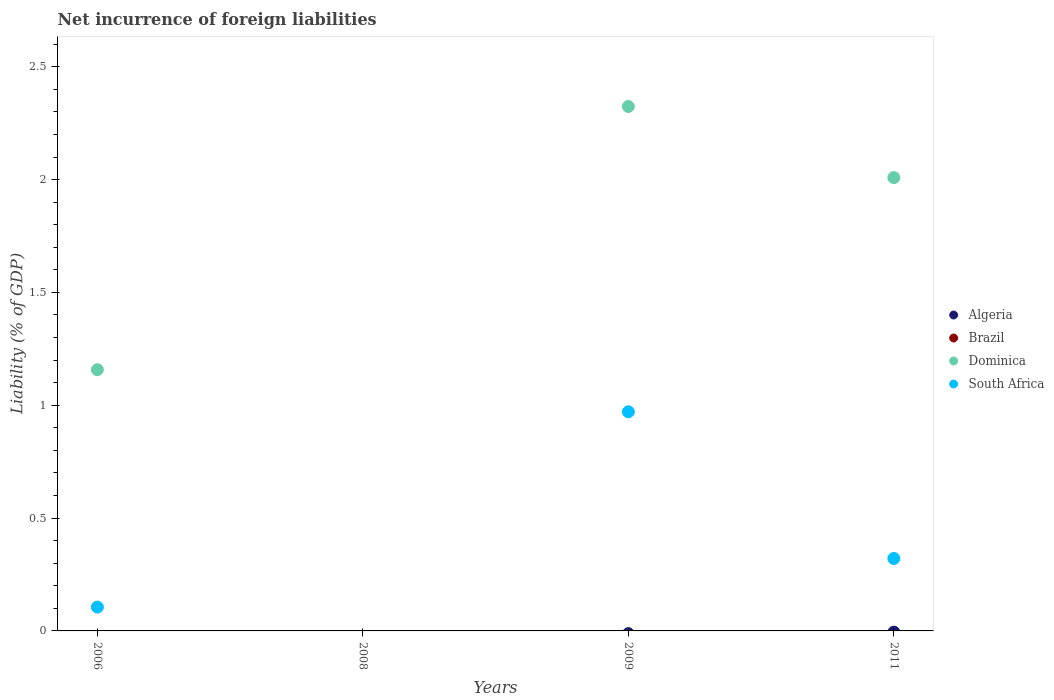What is the net incurrence of foreign liabilities in South Africa in 2011?
Your answer should be compact. 0.32. Across all years, what is the minimum net incurrence of foreign liabilities in South Africa?
Give a very brief answer. 0. What is the difference between the net incurrence of foreign liabilities in Dominica in 2011 and the net incurrence of foreign liabilities in Algeria in 2008?
Make the answer very short. 2.01. What is the average net incurrence of foreign liabilities in Algeria per year?
Provide a short and direct response. 0. In the year 2006, what is the difference between the net incurrence of foreign liabilities in Dominica and net incurrence of foreign liabilities in South Africa?
Offer a terse response. 1.05. In how many years, is the net incurrence of foreign liabilities in Algeria greater than 1.6 %?
Ensure brevity in your answer.  0. Is the difference between the net incurrence of foreign liabilities in Dominica in 2009 and 2011 greater than the difference between the net incurrence of foreign liabilities in South Africa in 2009 and 2011?
Give a very brief answer. No. What is the difference between the highest and the lowest net incurrence of foreign liabilities in Dominica?
Keep it short and to the point. 2.32. In how many years, is the net incurrence of foreign liabilities in Algeria greater than the average net incurrence of foreign liabilities in Algeria taken over all years?
Provide a succinct answer. 0. Is it the case that in every year, the sum of the net incurrence of foreign liabilities in South Africa and net incurrence of foreign liabilities in Dominica  is greater than the net incurrence of foreign liabilities in Algeria?
Offer a terse response. No. Are the values on the major ticks of Y-axis written in scientific E-notation?
Your answer should be very brief. No. Where does the legend appear in the graph?
Offer a terse response. Center right. What is the title of the graph?
Keep it short and to the point. Net incurrence of foreign liabilities. Does "Comoros" appear as one of the legend labels in the graph?
Your answer should be compact. No. What is the label or title of the X-axis?
Offer a terse response. Years. What is the label or title of the Y-axis?
Provide a succinct answer. Liability (% of GDP). What is the Liability (% of GDP) of Brazil in 2006?
Your answer should be very brief. 0. What is the Liability (% of GDP) in Dominica in 2006?
Your response must be concise. 1.16. What is the Liability (% of GDP) of South Africa in 2006?
Give a very brief answer. 0.11. What is the Liability (% of GDP) of Algeria in 2008?
Make the answer very short. 0. What is the Liability (% of GDP) of Dominica in 2008?
Provide a short and direct response. 0. What is the Liability (% of GDP) in Algeria in 2009?
Ensure brevity in your answer.  0. What is the Liability (% of GDP) in Dominica in 2009?
Ensure brevity in your answer.  2.32. What is the Liability (% of GDP) in South Africa in 2009?
Provide a succinct answer. 0.97. What is the Liability (% of GDP) in Brazil in 2011?
Offer a terse response. 0. What is the Liability (% of GDP) in Dominica in 2011?
Offer a very short reply. 2.01. What is the Liability (% of GDP) of South Africa in 2011?
Keep it short and to the point. 0.32. Across all years, what is the maximum Liability (% of GDP) of Dominica?
Ensure brevity in your answer.  2.32. Across all years, what is the maximum Liability (% of GDP) in South Africa?
Offer a terse response. 0.97. Across all years, what is the minimum Liability (% of GDP) in Dominica?
Offer a very short reply. 0. Across all years, what is the minimum Liability (% of GDP) in South Africa?
Provide a succinct answer. 0. What is the total Liability (% of GDP) of Dominica in the graph?
Ensure brevity in your answer.  5.49. What is the total Liability (% of GDP) of South Africa in the graph?
Ensure brevity in your answer.  1.4. What is the difference between the Liability (% of GDP) in Dominica in 2006 and that in 2009?
Provide a succinct answer. -1.17. What is the difference between the Liability (% of GDP) of South Africa in 2006 and that in 2009?
Offer a very short reply. -0.87. What is the difference between the Liability (% of GDP) in Dominica in 2006 and that in 2011?
Keep it short and to the point. -0.85. What is the difference between the Liability (% of GDP) of South Africa in 2006 and that in 2011?
Your response must be concise. -0.22. What is the difference between the Liability (% of GDP) of Dominica in 2009 and that in 2011?
Your response must be concise. 0.32. What is the difference between the Liability (% of GDP) in South Africa in 2009 and that in 2011?
Ensure brevity in your answer.  0.65. What is the difference between the Liability (% of GDP) in Dominica in 2006 and the Liability (% of GDP) in South Africa in 2009?
Your answer should be compact. 0.19. What is the difference between the Liability (% of GDP) in Dominica in 2006 and the Liability (% of GDP) in South Africa in 2011?
Keep it short and to the point. 0.84. What is the difference between the Liability (% of GDP) of Dominica in 2009 and the Liability (% of GDP) of South Africa in 2011?
Give a very brief answer. 2. What is the average Liability (% of GDP) in Algeria per year?
Ensure brevity in your answer.  0. What is the average Liability (% of GDP) of Brazil per year?
Provide a succinct answer. 0. What is the average Liability (% of GDP) of Dominica per year?
Offer a terse response. 1.37. What is the average Liability (% of GDP) in South Africa per year?
Offer a very short reply. 0.35. In the year 2006, what is the difference between the Liability (% of GDP) in Dominica and Liability (% of GDP) in South Africa?
Keep it short and to the point. 1.05. In the year 2009, what is the difference between the Liability (% of GDP) in Dominica and Liability (% of GDP) in South Africa?
Your answer should be compact. 1.35. In the year 2011, what is the difference between the Liability (% of GDP) in Dominica and Liability (% of GDP) in South Africa?
Your response must be concise. 1.69. What is the ratio of the Liability (% of GDP) of Dominica in 2006 to that in 2009?
Offer a terse response. 0.5. What is the ratio of the Liability (% of GDP) of South Africa in 2006 to that in 2009?
Provide a succinct answer. 0.11. What is the ratio of the Liability (% of GDP) in Dominica in 2006 to that in 2011?
Your answer should be compact. 0.58. What is the ratio of the Liability (% of GDP) in South Africa in 2006 to that in 2011?
Provide a short and direct response. 0.33. What is the ratio of the Liability (% of GDP) of Dominica in 2009 to that in 2011?
Offer a very short reply. 1.16. What is the ratio of the Liability (% of GDP) in South Africa in 2009 to that in 2011?
Offer a very short reply. 3.02. What is the difference between the highest and the second highest Liability (% of GDP) in Dominica?
Provide a succinct answer. 0.32. What is the difference between the highest and the second highest Liability (% of GDP) in South Africa?
Your answer should be compact. 0.65. What is the difference between the highest and the lowest Liability (% of GDP) of Dominica?
Keep it short and to the point. 2.32. What is the difference between the highest and the lowest Liability (% of GDP) in South Africa?
Offer a terse response. 0.97. 